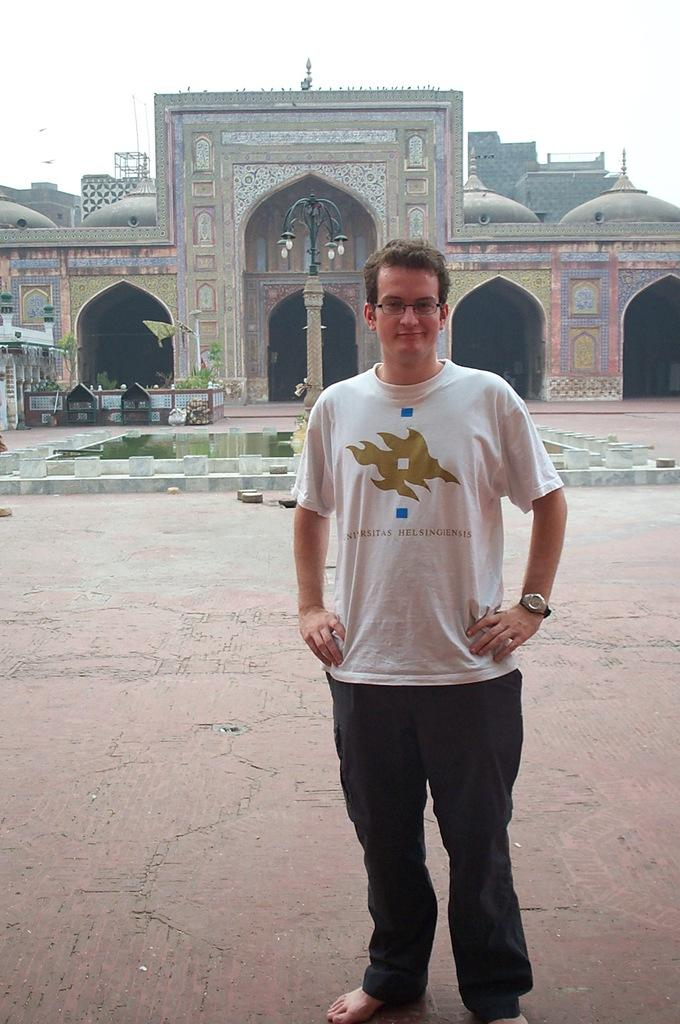Who is the main subject in the foreground of the picture? There is a man standing in the foreground of the picture. What is the man standing in front of? The man is standing in front of a mosque. What can be seen in the background of the picture? There is a fountain, the mosque, and the sky visible in the background of the picture. What type of glove is the man wearing in the picture? There is no glove visible in the picture; the man is not wearing any gloves. Is the man's father present in the picture? There is no information about the man's father in the picture, so it cannot be determined if he is present or not. 